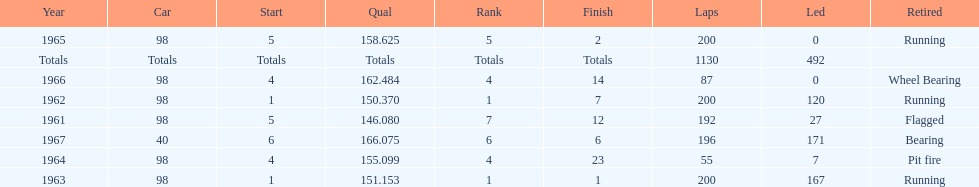What is the most common cause for a retired car? Running. 